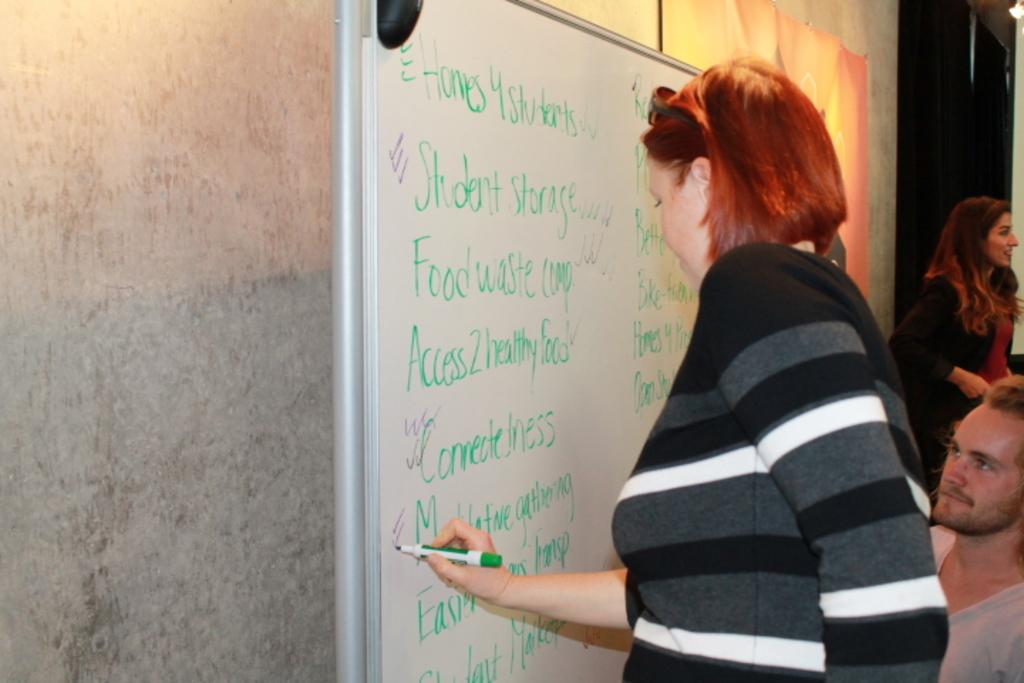What is the first thing that the lady wrote on the white board?
Provide a short and direct response. Homes 4 students. What is the last sentence say?
Your response must be concise. Connectedness. 